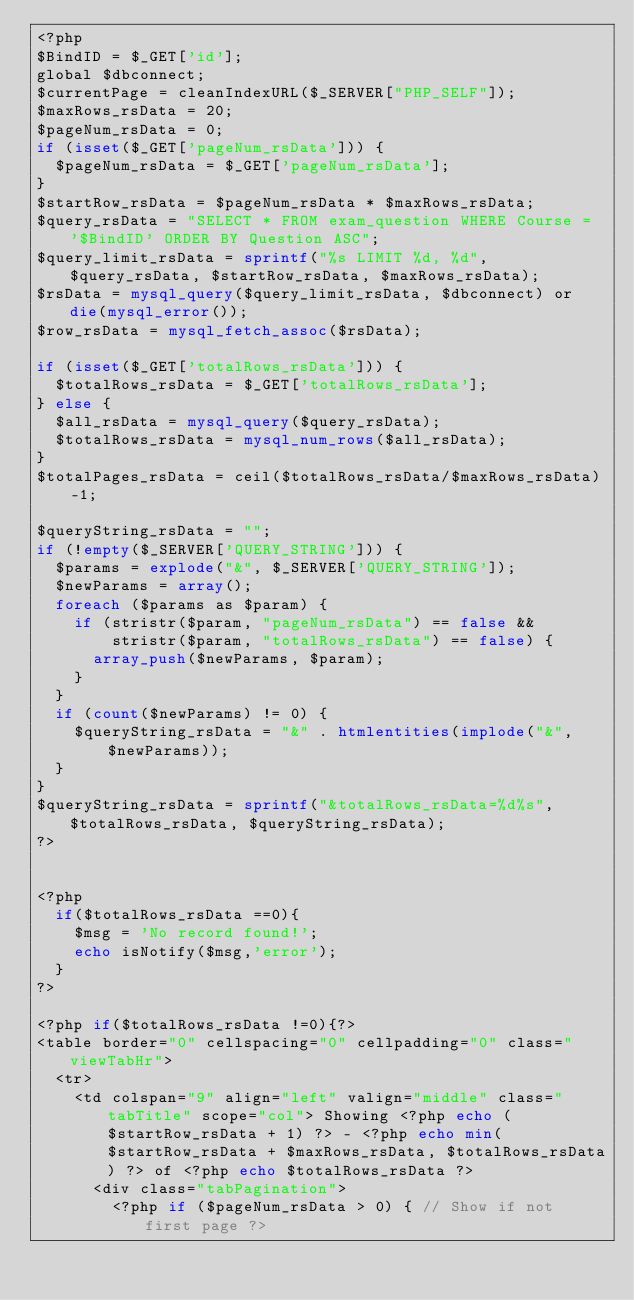<code> <loc_0><loc_0><loc_500><loc_500><_PHP_><?php
$BindID = $_GET['id'];
global $dbconnect;
$currentPage = cleanIndexURL($_SERVER["PHP_SELF"]);
$maxRows_rsData = 20;
$pageNum_rsData = 0;
if (isset($_GET['pageNum_rsData'])) {
  $pageNum_rsData = $_GET['pageNum_rsData'];
}
$startRow_rsData = $pageNum_rsData * $maxRows_rsData;
$query_rsData = "SELECT * FROM exam_question WHERE Course = '$BindID' ORDER BY Question ASC";
$query_limit_rsData = sprintf("%s LIMIT %d, %d", $query_rsData, $startRow_rsData, $maxRows_rsData);
$rsData = mysql_query($query_limit_rsData, $dbconnect) or die(mysql_error());
$row_rsData = mysql_fetch_assoc($rsData);

if (isset($_GET['totalRows_rsData'])) {
  $totalRows_rsData = $_GET['totalRows_rsData'];
} else {
  $all_rsData = mysql_query($query_rsData);
  $totalRows_rsData = mysql_num_rows($all_rsData);
}
$totalPages_rsData = ceil($totalRows_rsData/$maxRows_rsData)-1;

$queryString_rsData = "";
if (!empty($_SERVER['QUERY_STRING'])) {
  $params = explode("&", $_SERVER['QUERY_STRING']);
  $newParams = array();
  foreach ($params as $param) {
    if (stristr($param, "pageNum_rsData") == false && 
        stristr($param, "totalRows_rsData") == false) {
      array_push($newParams, $param);
    }
  }
  if (count($newParams) != 0) {
    $queryString_rsData = "&" . htmlentities(implode("&", $newParams));
  }
}
$queryString_rsData = sprintf("&totalRows_rsData=%d%s", $totalRows_rsData, $queryString_rsData);
?>


<?php
	if($totalRows_rsData ==0){
		$msg = 'No record found!';
		echo isNotify($msg,'error');
	}
?>

<?php if($totalRows_rsData !=0){?>
<table border="0" cellspacing="0" cellpadding="0" class="viewTabHr">
  <tr>
    <td colspan="9" align="left" valign="middle" class="tabTitle" scope="col"> Showing <?php echo ($startRow_rsData + 1) ?> - <?php echo min($startRow_rsData + $maxRows_rsData, $totalRows_rsData) ?> of <?php echo $totalRows_rsData ?>
      <div class="tabPagination">
        <?php if ($pageNum_rsData > 0) { // Show if not first page ?></code> 